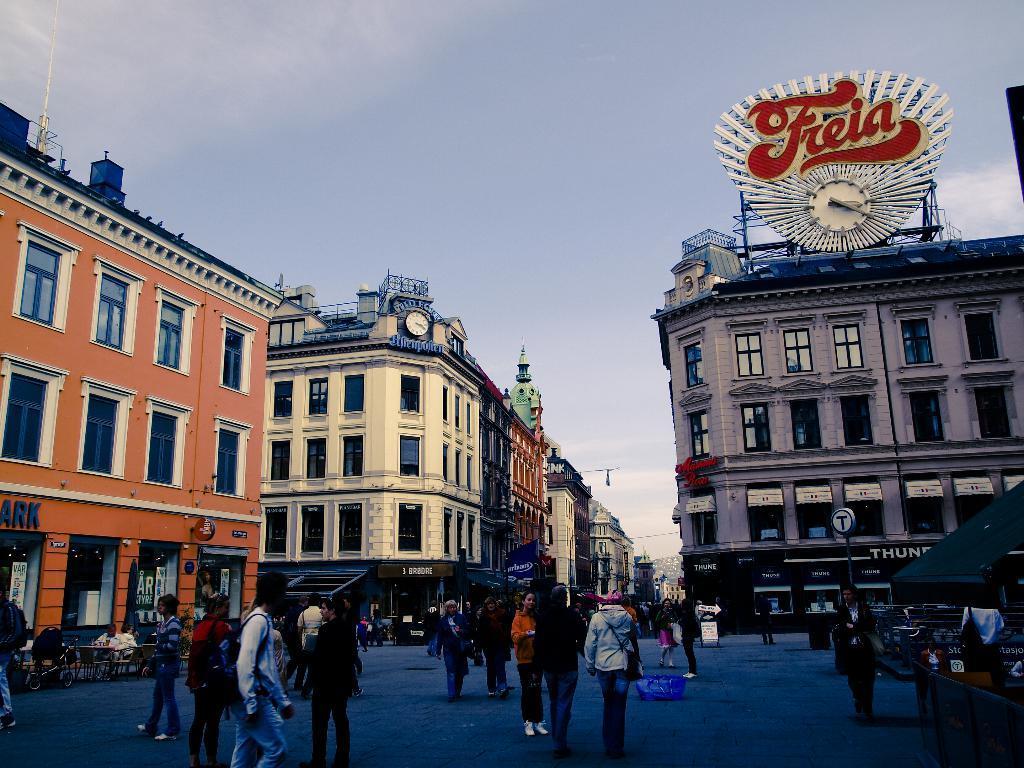How would you summarize this image in a sentence or two? In this picture I can see group of people standing on the road, there are chairs, tables, buildings, poles, clocks, boards, and in the background there is sky. 